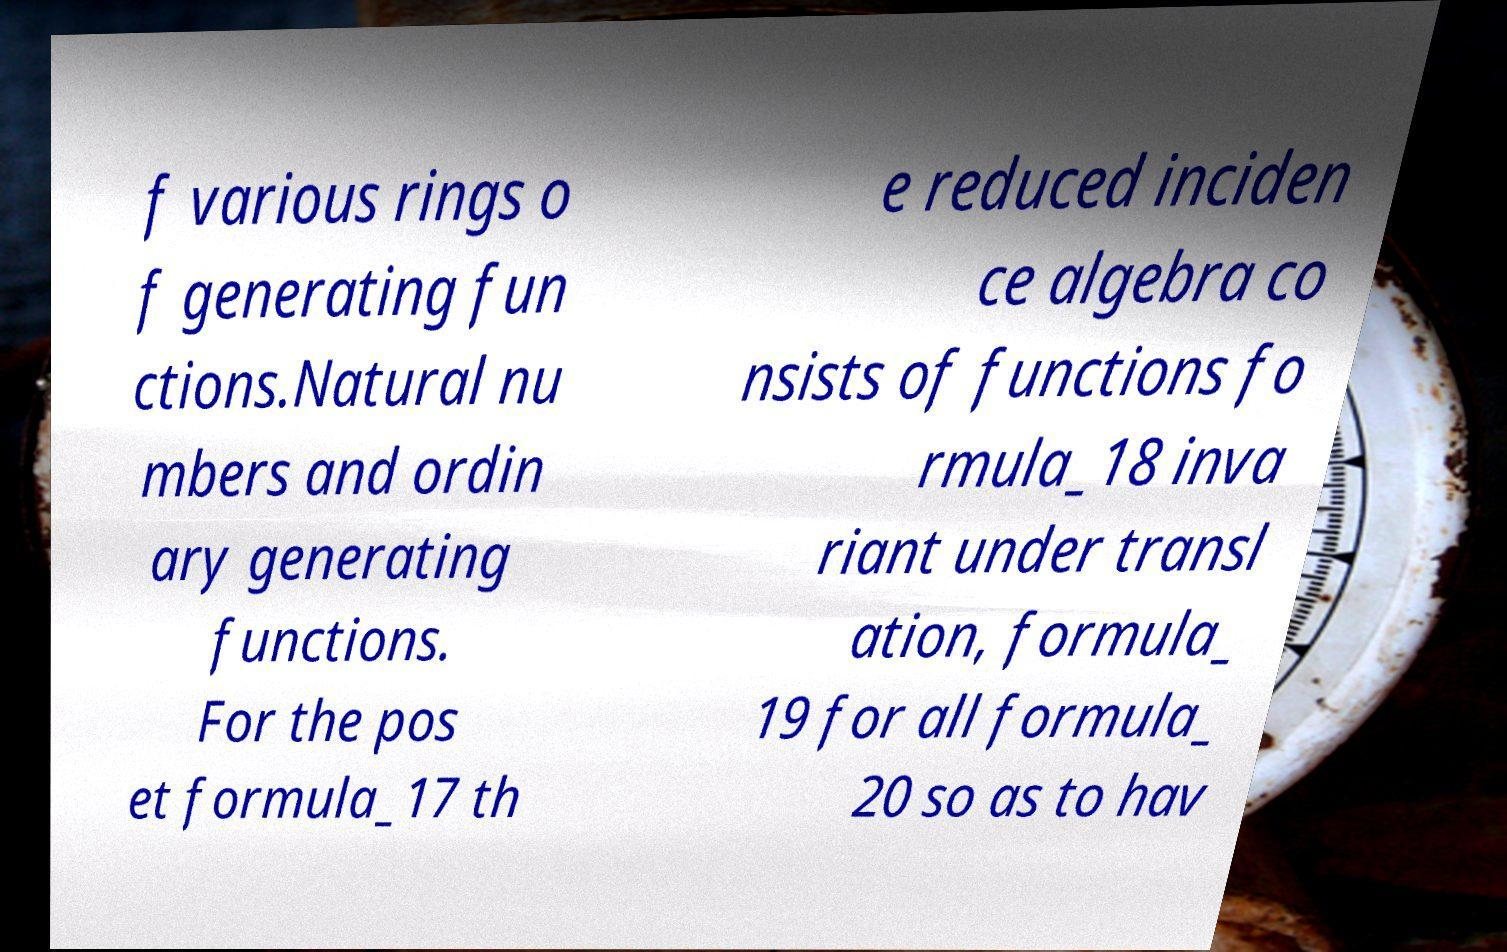Please identify and transcribe the text found in this image. f various rings o f generating fun ctions.Natural nu mbers and ordin ary generating functions. For the pos et formula_17 th e reduced inciden ce algebra co nsists of functions fo rmula_18 inva riant under transl ation, formula_ 19 for all formula_ 20 so as to hav 